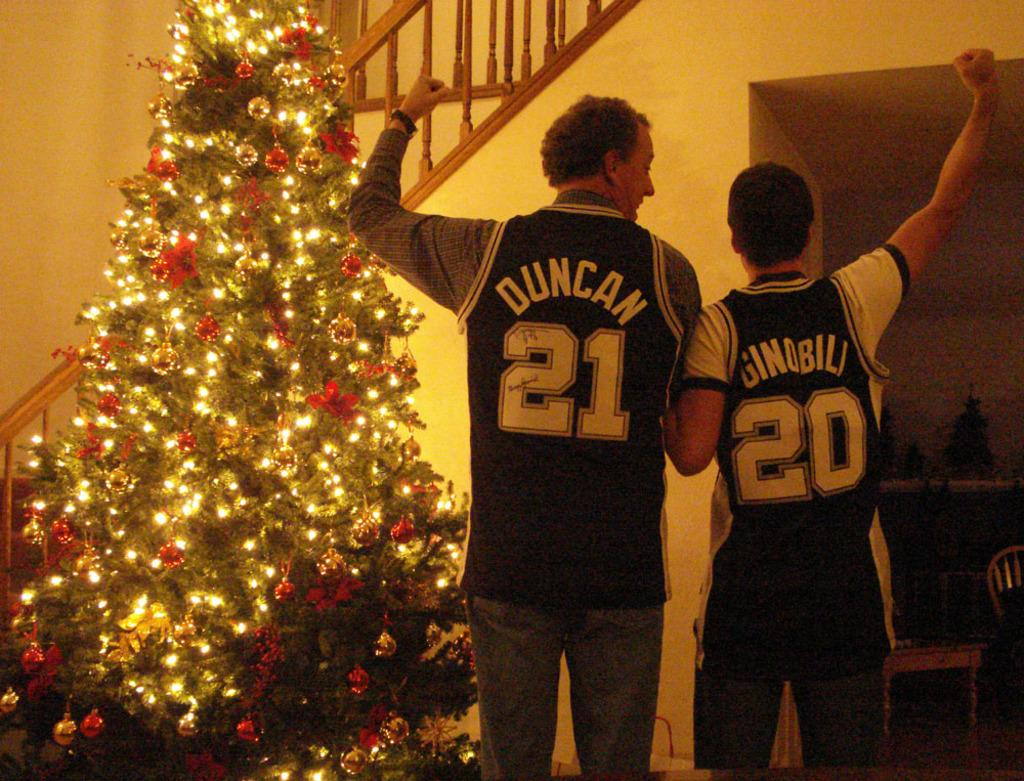<image>
Describe the image concisely. Two men wearing basketball jerseys numbered 21 and 20 celebrate in front of a Christmas tree. 